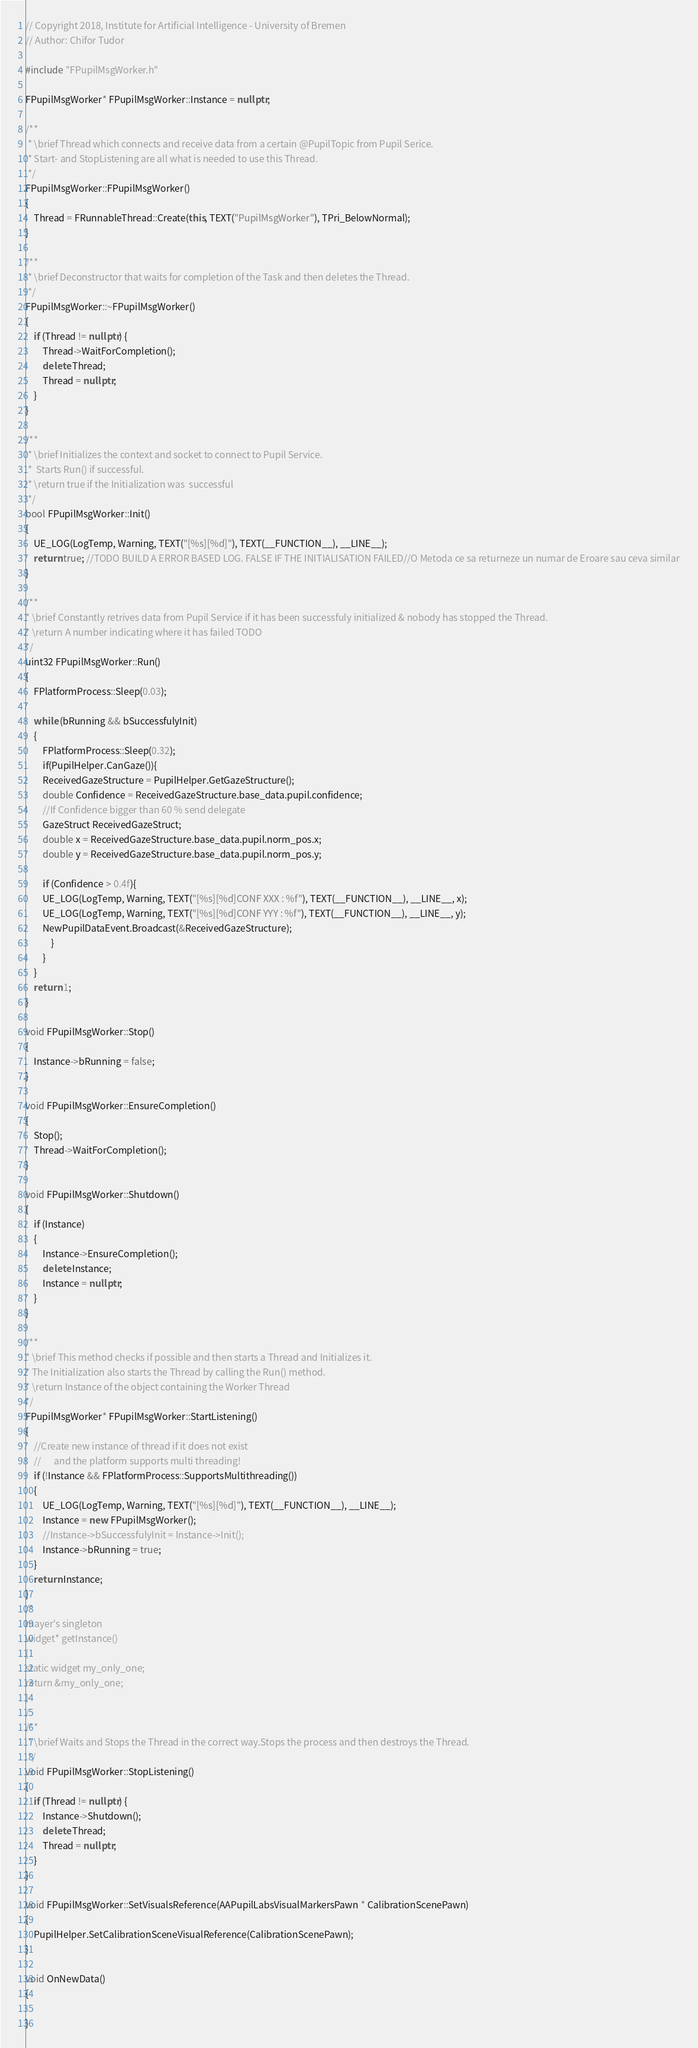Convert code to text. <code><loc_0><loc_0><loc_500><loc_500><_C++_>// Copyright 2018, Institute for Artificial Intelligence - University of Bremen
// Author: Chifor Tudor

#include "FPupilMsgWorker.h"

FPupilMsgWorker* FPupilMsgWorker::Instance = nullptr;

/**
 * \brief Thread which connects and receive data from a certain @PupilTopic from Pupil Serice.
 * Start- and StopListening are all what is needed to use this Thread.
 */
FPupilMsgWorker::FPupilMsgWorker()
{
	Thread = FRunnableThread::Create(this, TEXT("PupilMsgWorker"), TPri_BelowNormal);
}

/**
 * \brief Deconstructor that waits for completion of the Task and then deletes the Thread.
 */
FPupilMsgWorker::~FPupilMsgWorker()
{
	if (Thread != nullptr) {
		Thread->WaitForCompletion();
		delete Thread;
		Thread = nullptr;
	}
}

/**
 * \brief Initializes the context and socket to connect to Pupil Service.
 *	Starts Run() if successful.
 * \return true if the Initialization was  successful
 */
bool FPupilMsgWorker::Init()
{
	UE_LOG(LogTemp, Warning, TEXT("[%s][%d]"), TEXT(__FUNCTION__), __LINE__);
	return true; //TODO BUILD A ERROR BASED LOG. FALSE IF THE INITIALISATION FAILED//O Metoda ce sa returneze un numar de Eroare sau ceva similar
}

/**
* \brief Constantly retrives data from Pupil Service if it has been successfuly initialized & nobody has stopped the Thread.
* \return A number indicating where it has failed TODO
*/
uint32 FPupilMsgWorker::Run()
{
	FPlatformProcess::Sleep(0.03);

	while (bRunning && bSuccessfulyInit)
	{
		FPlatformProcess::Sleep(0.32);
		if(PupilHelper.CanGaze()){
		ReceivedGazeStructure = PupilHelper.GetGazeStructure();
		double Confidence = ReceivedGazeStructure.base_data.pupil.confidence;
		//If Confidence bigger than 60 % send delegate
		GazeStruct ReceivedGazeStruct;
		double x = ReceivedGazeStructure.base_data.pupil.norm_pos.x;
		double y = ReceivedGazeStructure.base_data.pupil.norm_pos.y;

		if (Confidence > 0.4f){
		UE_LOG(LogTemp, Warning, TEXT("[%s][%d]CONF XXX : %f"), TEXT(__FUNCTION__), __LINE__, x);
		UE_LOG(LogTemp, Warning, TEXT("[%s][%d]CONF YYY : %f"), TEXT(__FUNCTION__), __LINE__, y);
		NewPupilDataEvent.Broadcast(&ReceivedGazeStructure);
			}
		}
	}
	return 1;
}

void FPupilMsgWorker::Stop()
{
	Instance->bRunning = false;
}

void FPupilMsgWorker::EnsureCompletion()
{
	Stop();
	Thread->WaitForCompletion();
}

void FPupilMsgWorker::Shutdown()
{
	if (Instance)
	{
		Instance->EnsureCompletion();
		delete Instance;
		Instance = nullptr;
	}
}

/**
* \brief This method checks if possible and then starts a Thread and Initializes it.
* The Initialization also starts the Thread by calling the Run() method.
* \return Instance of the object containing the Worker Thread
*/
FPupilMsgWorker* FPupilMsgWorker::StartListening()
{
	//Create new instance of thread if it does not exist
	//		and the platform supports multi threading!
	if (!Instance && FPlatformProcess::SupportsMultithreading())
	{
		UE_LOG(LogTemp, Warning, TEXT("[%s][%d]"), TEXT(__FUNCTION__), __LINE__);
		Instance = new FPupilMsgWorker();
		//Instance->bSuccessfulyInit = Instance->Init();
		Instance->bRunning = true;
	}
	return Instance;
}
/*
mayer's singleton
widget* getInstance()
{
static widget my_only_one;
return &my_only_one;
}
/
/**
 * \brief Waits and Stops the Thread in the correct way.Stops the process and then destroys the Thread.
 */
void FPupilMsgWorker::StopListening()
{
	if (Thread != nullptr) {
		Instance->Shutdown();
		delete Thread;
		Thread = nullptr;
	}
}

void FPupilMsgWorker::SetVisualsReference(AAPupilLabsVisualMarkersPawn * CalibrationScenePawn)
{
	PupilHelper.SetCalibrationSceneVisualReference(CalibrationScenePawn);
}

void OnNewData()
{
	
}</code> 